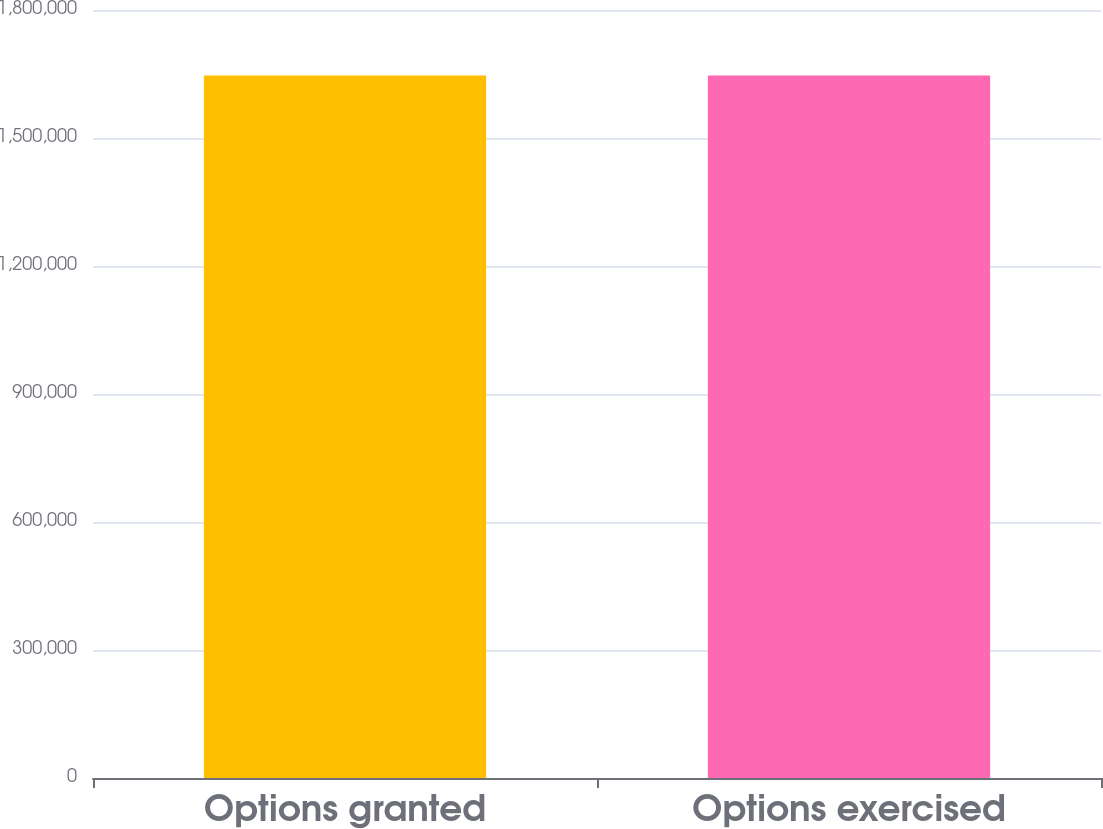<chart> <loc_0><loc_0><loc_500><loc_500><bar_chart><fcel>Options granted<fcel>Options exercised<nl><fcel>1.64652e+06<fcel>1.64652e+06<nl></chart> 